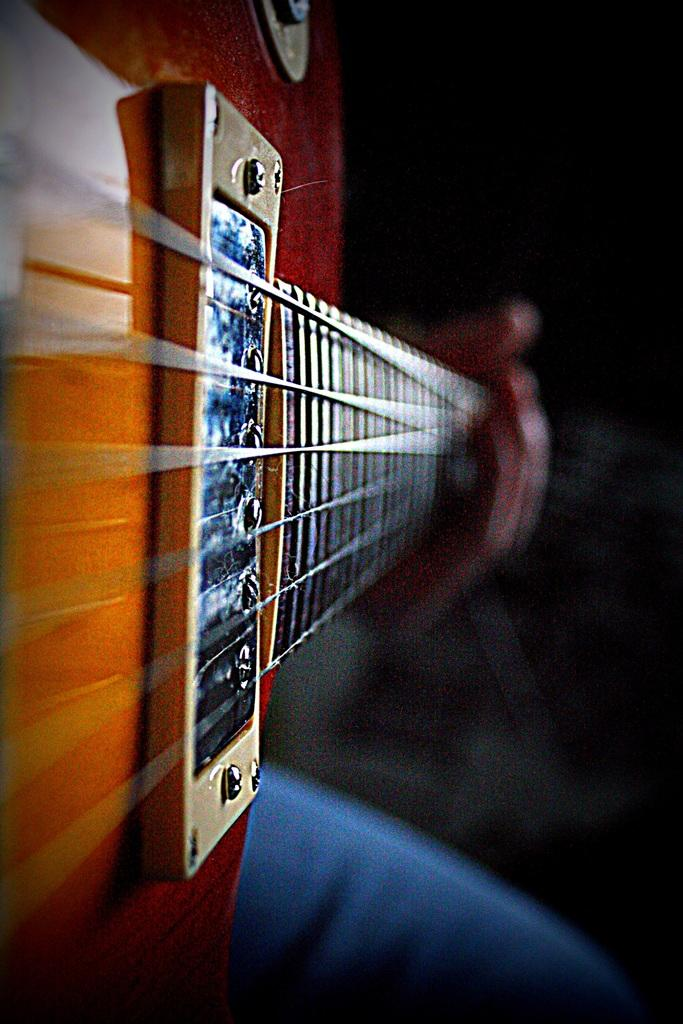What is the main subject of the image? There is a person in the image. What is the person holding in the image? The person is holding a guitar. Can you describe the background of the image? The background of the image is dark. How many tigers can be seen playing with the children in the image? There are no tigers or children present in the image; it features a person holding a guitar against a dark background. 